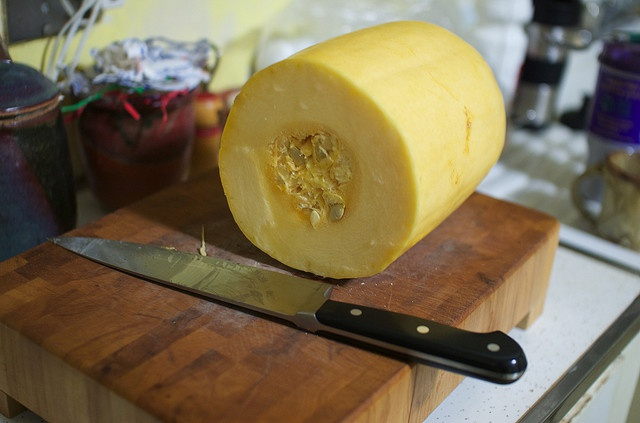Describe the objects in this image and their specific colors. I can see knife in gray, black, and olive tones and cup in gray, black, navy, and blue tones in this image. 